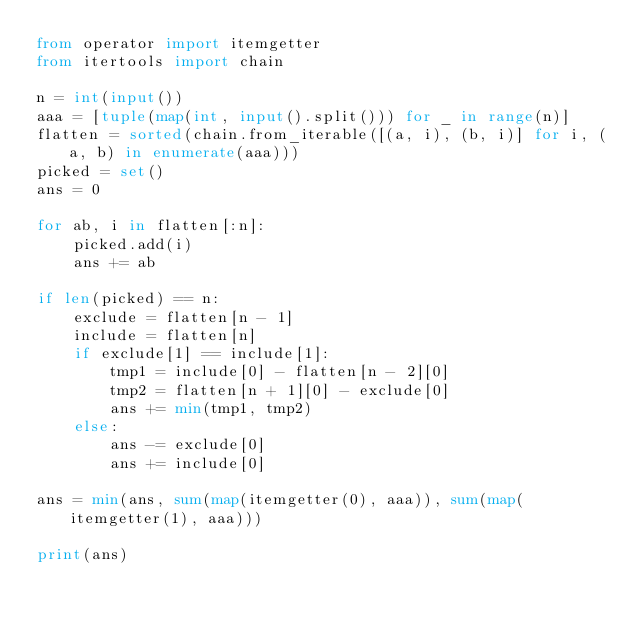<code> <loc_0><loc_0><loc_500><loc_500><_Python_>from operator import itemgetter
from itertools import chain

n = int(input())
aaa = [tuple(map(int, input().split())) for _ in range(n)]
flatten = sorted(chain.from_iterable([(a, i), (b, i)] for i, (a, b) in enumerate(aaa)))
picked = set()
ans = 0

for ab, i in flatten[:n]:
    picked.add(i)
    ans += ab

if len(picked) == n:
    exclude = flatten[n - 1]
    include = flatten[n]
    if exclude[1] == include[1]:
        tmp1 = include[0] - flatten[n - 2][0]
        tmp2 = flatten[n + 1][0] - exclude[0]
        ans += min(tmp1, tmp2)
    else:
        ans -= exclude[0]
        ans += include[0]

ans = min(ans, sum(map(itemgetter(0), aaa)), sum(map(itemgetter(1), aaa)))

print(ans)
</code> 